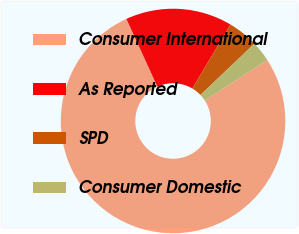<chart> <loc_0><loc_0><loc_500><loc_500><pie_chart><fcel>Consumer International<fcel>As Reported<fcel>SPD<fcel>Consumer Domestic<nl><fcel>77.32%<fcel>15.37%<fcel>4.36%<fcel>2.95%<nl></chart> 